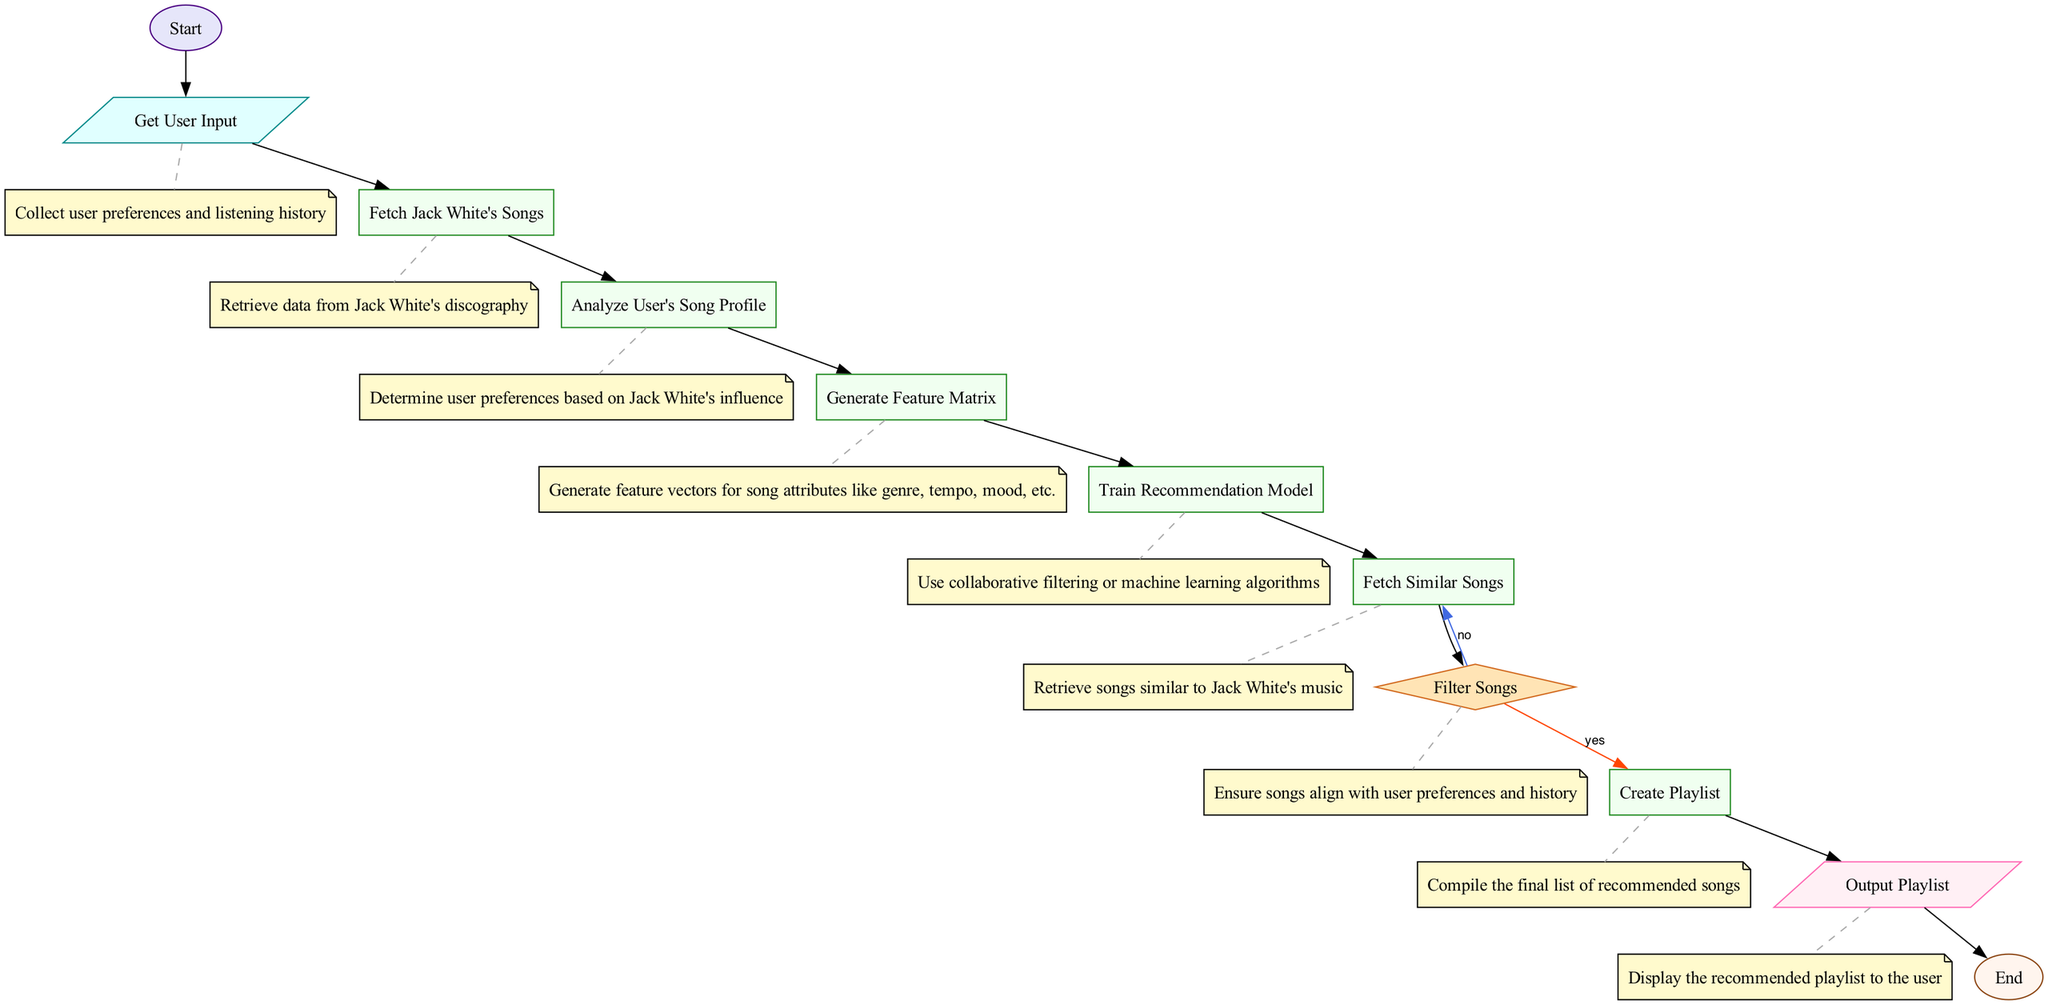What is the first node in the diagram? The first node in the diagram is labeled "Start," which indicates the beginning of the process of developing a playlist recommendation system.
Answer: Start How many processing steps are in the flowchart? There are five processing steps identified in the flowchart: "Fetch Jack White's Songs," "Analyze User's Song Profile," "Generate Feature Matrix," "Train Recommendation Model," and "Fetch Similar Songs."
Answer: Five What happens after "Filter Songs"? After "Filter Songs," if the condition is "yes," the flow proceeds to "Create Playlist," otherwise, it loops back to "Fetch Similar Songs" if the condition is "no."
Answer: Create Playlist or Fetch Similar Songs How many output steps are there in the diagram? There is one output step in the diagram, labeled "Output Playlist," which indicates the completion of the playlist recommendation process.
Answer: One What type of node directly follows "Train Recommendation Model"? The node that directly follows "Train Recommendation Model" is a process node labeled "Fetch Similar Songs," indicating that songs aligned with the trained model will be retrieved next.
Answer: Fetch Similar Songs If a user input is received, what is the next action taken? After receiving user input, the next action taken is to "Fetch Jack White's Songs," which retrieves information from his discography to use in generating recommendations.
Answer: Fetch Jack White's Songs What is the condition for moving to "Create Playlist"? The condition for moving to "Create Playlist" is a positive decision from the "Filter Songs" step, specifically when the answer is "yes," indicating that the filtered songs align with user preferences.
Answer: Yes How many edges connect the "Output Playlist" node? The "Output Playlist" node is connected by one edge that leads to the "End" node, indicating the end of the process once the recommended playlist is shown to the user.
Answer: One What type of node is "Filter Songs"? "Filter Songs" is a decision node, as it presents a conditional branching point in the flowchart to determine the next steps based on user preferences.
Answer: Decision node 